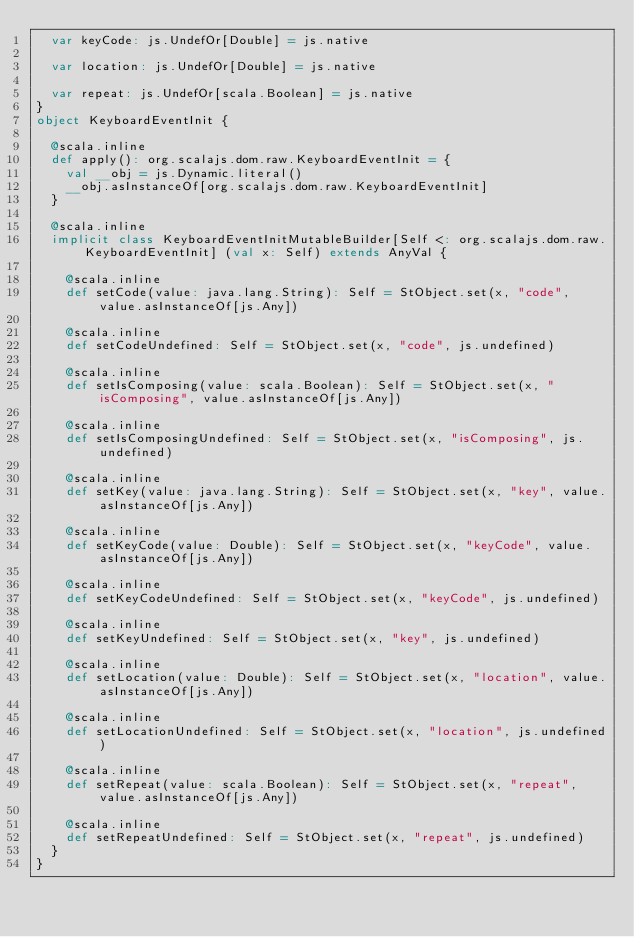Convert code to text. <code><loc_0><loc_0><loc_500><loc_500><_Scala_>  var keyCode: js.UndefOr[Double] = js.native
  
  var location: js.UndefOr[Double] = js.native
  
  var repeat: js.UndefOr[scala.Boolean] = js.native
}
object KeyboardEventInit {
  
  @scala.inline
  def apply(): org.scalajs.dom.raw.KeyboardEventInit = {
    val __obj = js.Dynamic.literal()
    __obj.asInstanceOf[org.scalajs.dom.raw.KeyboardEventInit]
  }
  
  @scala.inline
  implicit class KeyboardEventInitMutableBuilder[Self <: org.scalajs.dom.raw.KeyboardEventInit] (val x: Self) extends AnyVal {
    
    @scala.inline
    def setCode(value: java.lang.String): Self = StObject.set(x, "code", value.asInstanceOf[js.Any])
    
    @scala.inline
    def setCodeUndefined: Self = StObject.set(x, "code", js.undefined)
    
    @scala.inline
    def setIsComposing(value: scala.Boolean): Self = StObject.set(x, "isComposing", value.asInstanceOf[js.Any])
    
    @scala.inline
    def setIsComposingUndefined: Self = StObject.set(x, "isComposing", js.undefined)
    
    @scala.inline
    def setKey(value: java.lang.String): Self = StObject.set(x, "key", value.asInstanceOf[js.Any])
    
    @scala.inline
    def setKeyCode(value: Double): Self = StObject.set(x, "keyCode", value.asInstanceOf[js.Any])
    
    @scala.inline
    def setKeyCodeUndefined: Self = StObject.set(x, "keyCode", js.undefined)
    
    @scala.inline
    def setKeyUndefined: Self = StObject.set(x, "key", js.undefined)
    
    @scala.inline
    def setLocation(value: Double): Self = StObject.set(x, "location", value.asInstanceOf[js.Any])
    
    @scala.inline
    def setLocationUndefined: Self = StObject.set(x, "location", js.undefined)
    
    @scala.inline
    def setRepeat(value: scala.Boolean): Self = StObject.set(x, "repeat", value.asInstanceOf[js.Any])
    
    @scala.inline
    def setRepeatUndefined: Self = StObject.set(x, "repeat", js.undefined)
  }
}
</code> 